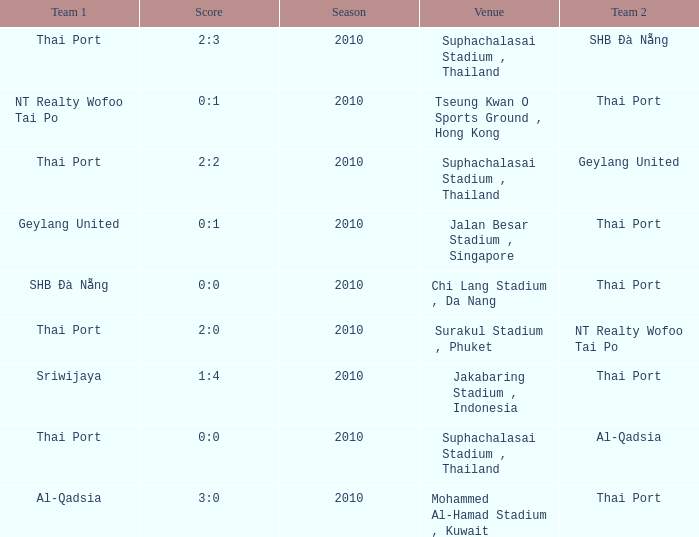What was the score for the game in which Al-Qadsia was Team 2? 0:0. 